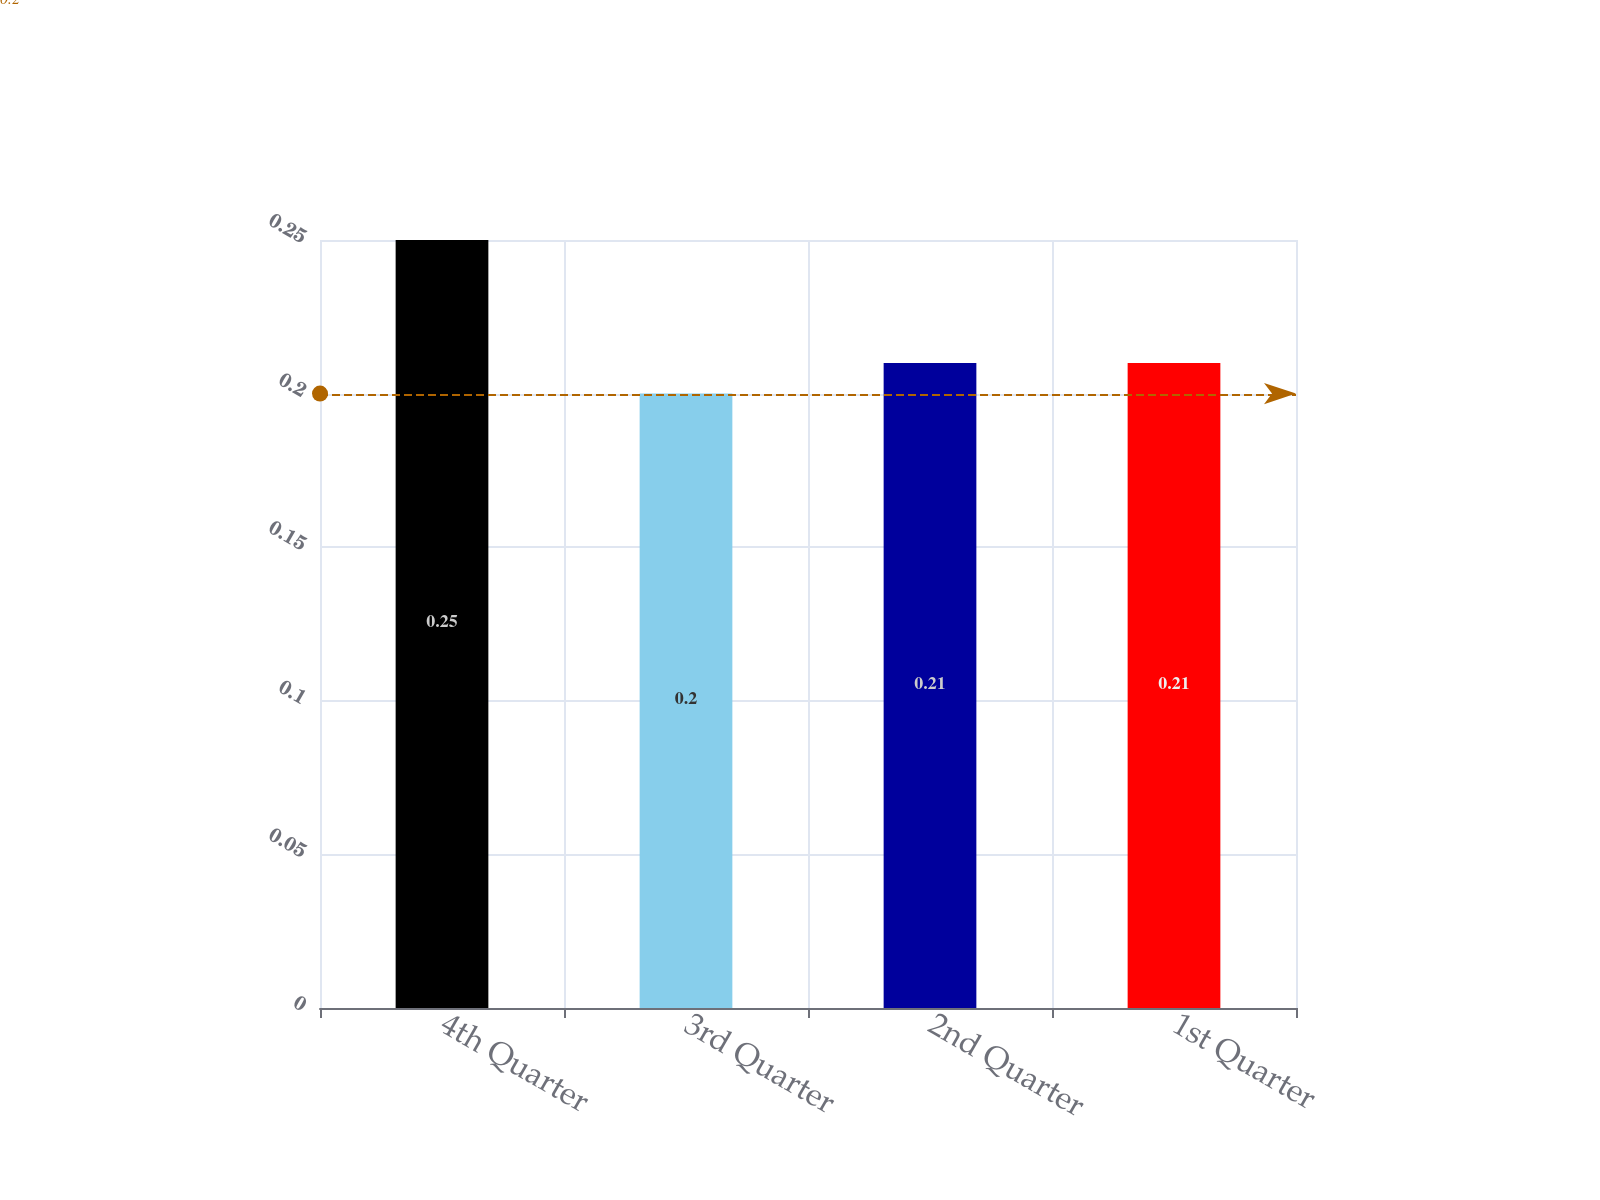Convert chart to OTSL. <chart><loc_0><loc_0><loc_500><loc_500><bar_chart><fcel>4th Quarter<fcel>3rd Quarter<fcel>2nd Quarter<fcel>1st Quarter<nl><fcel>0.25<fcel>0.2<fcel>0.21<fcel>0.21<nl></chart> 